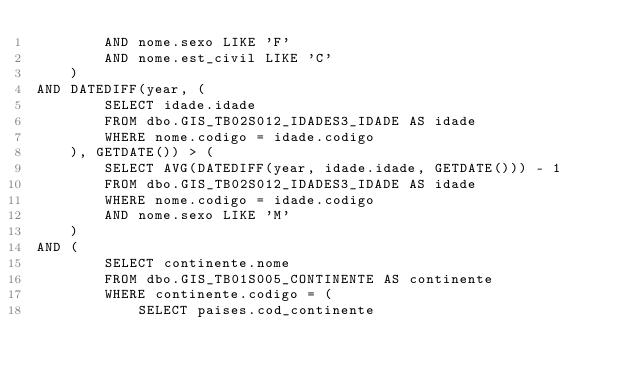Convert code to text. <code><loc_0><loc_0><loc_500><loc_500><_SQL_>		AND nome.sexo LIKE 'F'
		AND nome.est_civil LIKE 'C'
	)
AND DATEDIFF(year, (
		SELECT idade.idade 
		FROM dbo.GIS_TB02S012_IDADES3_IDADE AS idade
		WHERE nome.codigo = idade.codigo
	), GETDATE()) > (
		SELECT AVG(DATEDIFF(year, idade.idade, GETDATE())) - 1
		FROM dbo.GIS_TB02S012_IDADES3_IDADE AS idade
		WHERE nome.codigo = idade.codigo
		AND nome.sexo LIKE 'M'
	)
AND (
		SELECT continente.nome 
		FROM dbo.GIS_TB01S005_CONTINENTE AS continente
		WHERE continente.codigo = (
			SELECT paises.cod_continente </code> 